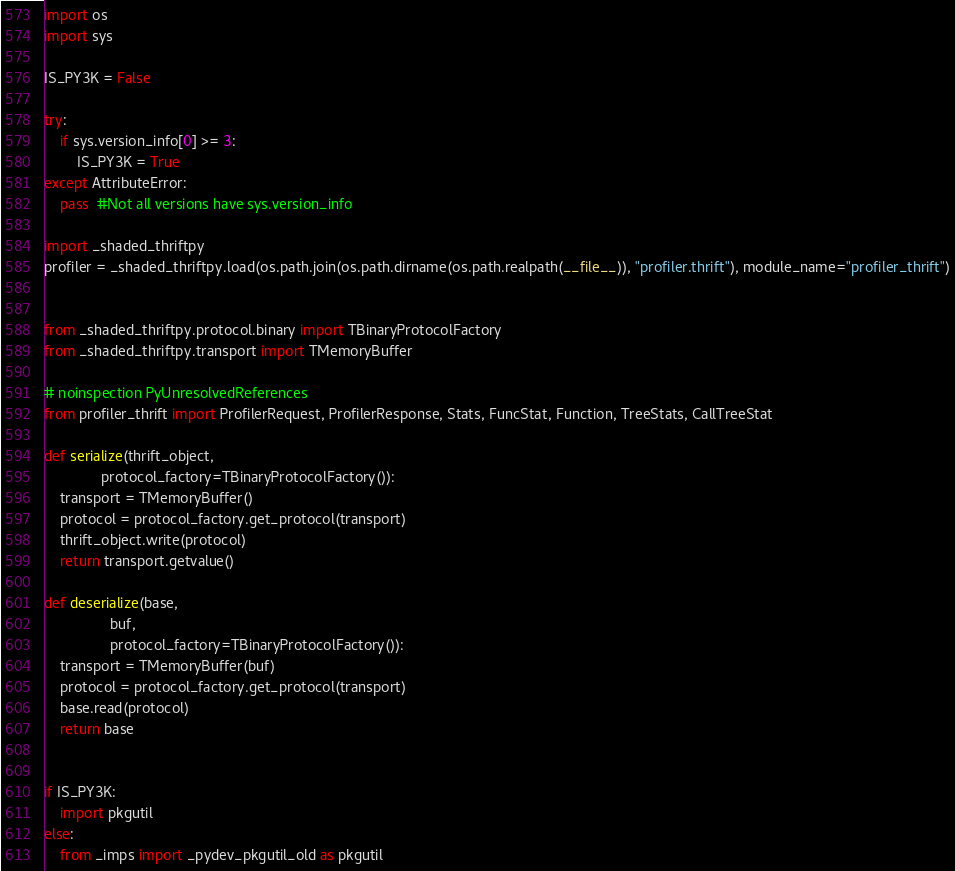<code> <loc_0><loc_0><loc_500><loc_500><_Python_>import os
import sys

IS_PY3K = False

try:
    if sys.version_info[0] >= 3:
        IS_PY3K = True
except AttributeError:
    pass  #Not all versions have sys.version_info

import _shaded_thriftpy
profiler = _shaded_thriftpy.load(os.path.join(os.path.dirname(os.path.realpath(__file__)), "profiler.thrift"), module_name="profiler_thrift")


from _shaded_thriftpy.protocol.binary import TBinaryProtocolFactory
from _shaded_thriftpy.transport import TMemoryBuffer

# noinspection PyUnresolvedReferences
from profiler_thrift import ProfilerRequest, ProfilerResponse, Stats, FuncStat, Function, TreeStats, CallTreeStat

def serialize(thrift_object,
              protocol_factory=TBinaryProtocolFactory()):
    transport = TMemoryBuffer()
    protocol = protocol_factory.get_protocol(transport)
    thrift_object.write(protocol)
    return transport.getvalue()

def deserialize(base,
                buf,
                protocol_factory=TBinaryProtocolFactory()):
    transport = TMemoryBuffer(buf)
    protocol = protocol_factory.get_protocol(transport)
    base.read(protocol)
    return base


if IS_PY3K:
    import pkgutil
else:
    from _imps import _pydev_pkgutil_old as pkgutil</code> 